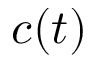<formula> <loc_0><loc_0><loc_500><loc_500>c ( t )</formula> 